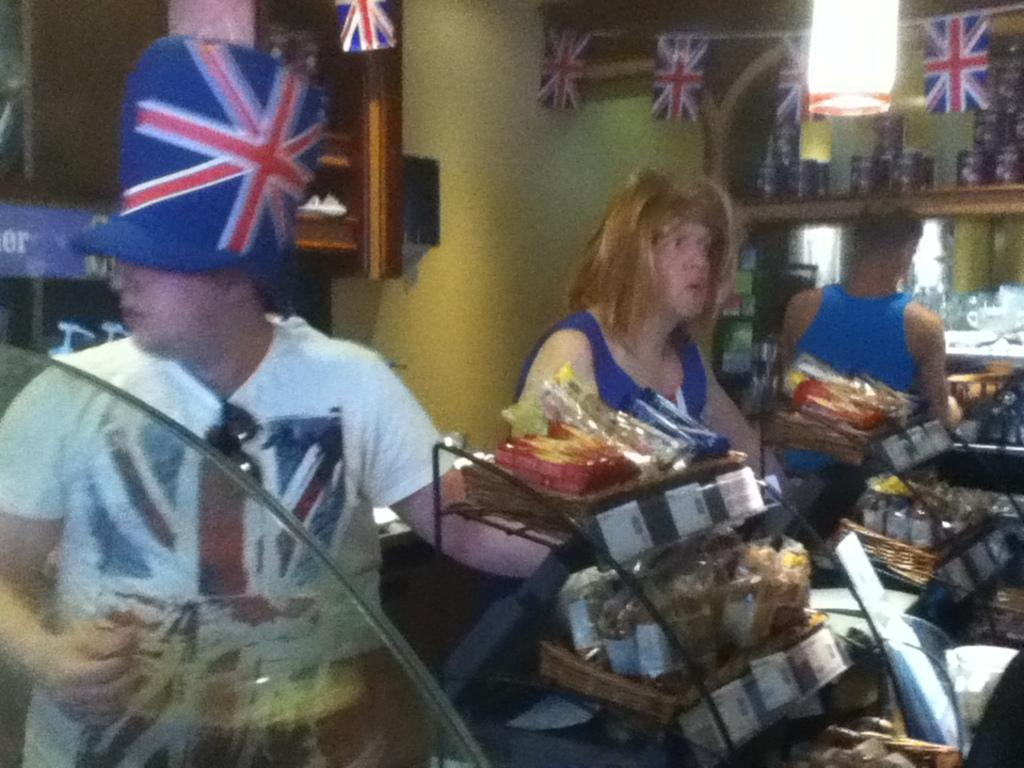What is happening in the image? There are people standing in the image. What else can be seen in the image besides the people? There are food items and small flags in the image. What is the background of the image? There is a wall visible in the image. What type of paper is being read by the clam in the image? There is no clam or paper present in the image. 